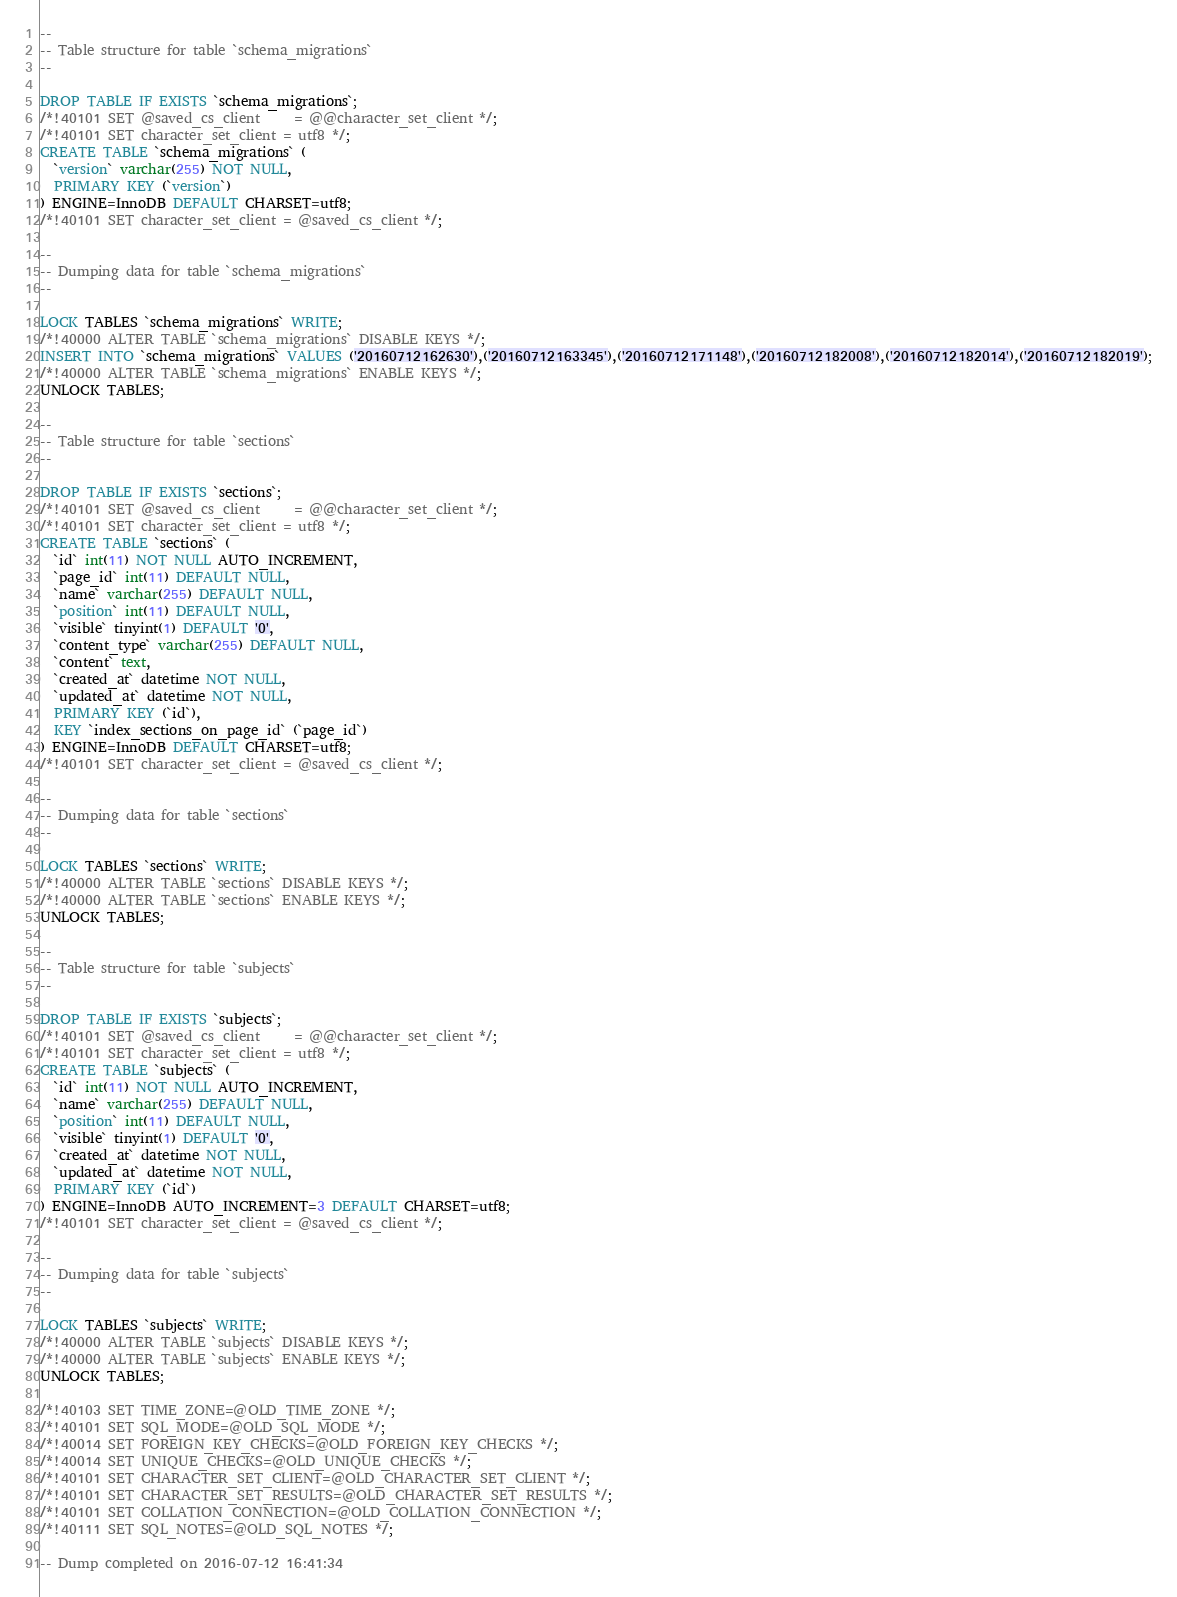<code> <loc_0><loc_0><loc_500><loc_500><_SQL_>--
-- Table structure for table `schema_migrations`
--

DROP TABLE IF EXISTS `schema_migrations`;
/*!40101 SET @saved_cs_client     = @@character_set_client */;
/*!40101 SET character_set_client = utf8 */;
CREATE TABLE `schema_migrations` (
  `version` varchar(255) NOT NULL,
  PRIMARY KEY (`version`)
) ENGINE=InnoDB DEFAULT CHARSET=utf8;
/*!40101 SET character_set_client = @saved_cs_client */;

--
-- Dumping data for table `schema_migrations`
--

LOCK TABLES `schema_migrations` WRITE;
/*!40000 ALTER TABLE `schema_migrations` DISABLE KEYS */;
INSERT INTO `schema_migrations` VALUES ('20160712162630'),('20160712163345'),('20160712171148'),('20160712182008'),('20160712182014'),('20160712182019');
/*!40000 ALTER TABLE `schema_migrations` ENABLE KEYS */;
UNLOCK TABLES;

--
-- Table structure for table `sections`
--

DROP TABLE IF EXISTS `sections`;
/*!40101 SET @saved_cs_client     = @@character_set_client */;
/*!40101 SET character_set_client = utf8 */;
CREATE TABLE `sections` (
  `id` int(11) NOT NULL AUTO_INCREMENT,
  `page_id` int(11) DEFAULT NULL,
  `name` varchar(255) DEFAULT NULL,
  `position` int(11) DEFAULT NULL,
  `visible` tinyint(1) DEFAULT '0',
  `content_type` varchar(255) DEFAULT NULL,
  `content` text,
  `created_at` datetime NOT NULL,
  `updated_at` datetime NOT NULL,
  PRIMARY KEY (`id`),
  KEY `index_sections_on_page_id` (`page_id`)
) ENGINE=InnoDB DEFAULT CHARSET=utf8;
/*!40101 SET character_set_client = @saved_cs_client */;

--
-- Dumping data for table `sections`
--

LOCK TABLES `sections` WRITE;
/*!40000 ALTER TABLE `sections` DISABLE KEYS */;
/*!40000 ALTER TABLE `sections` ENABLE KEYS */;
UNLOCK TABLES;

--
-- Table structure for table `subjects`
--

DROP TABLE IF EXISTS `subjects`;
/*!40101 SET @saved_cs_client     = @@character_set_client */;
/*!40101 SET character_set_client = utf8 */;
CREATE TABLE `subjects` (
  `id` int(11) NOT NULL AUTO_INCREMENT,
  `name` varchar(255) DEFAULT NULL,
  `position` int(11) DEFAULT NULL,
  `visible` tinyint(1) DEFAULT '0',
  `created_at` datetime NOT NULL,
  `updated_at` datetime NOT NULL,
  PRIMARY KEY (`id`)
) ENGINE=InnoDB AUTO_INCREMENT=3 DEFAULT CHARSET=utf8;
/*!40101 SET character_set_client = @saved_cs_client */;

--
-- Dumping data for table `subjects`
--

LOCK TABLES `subjects` WRITE;
/*!40000 ALTER TABLE `subjects` DISABLE KEYS */;
/*!40000 ALTER TABLE `subjects` ENABLE KEYS */;
UNLOCK TABLES;

/*!40103 SET TIME_ZONE=@OLD_TIME_ZONE */;
/*!40101 SET SQL_MODE=@OLD_SQL_MODE */;
/*!40014 SET FOREIGN_KEY_CHECKS=@OLD_FOREIGN_KEY_CHECKS */;
/*!40014 SET UNIQUE_CHECKS=@OLD_UNIQUE_CHECKS */;
/*!40101 SET CHARACTER_SET_CLIENT=@OLD_CHARACTER_SET_CLIENT */;
/*!40101 SET CHARACTER_SET_RESULTS=@OLD_CHARACTER_SET_RESULTS */;
/*!40101 SET COLLATION_CONNECTION=@OLD_COLLATION_CONNECTION */;
/*!40111 SET SQL_NOTES=@OLD_SQL_NOTES */;

-- Dump completed on 2016-07-12 16:41:34
</code> 